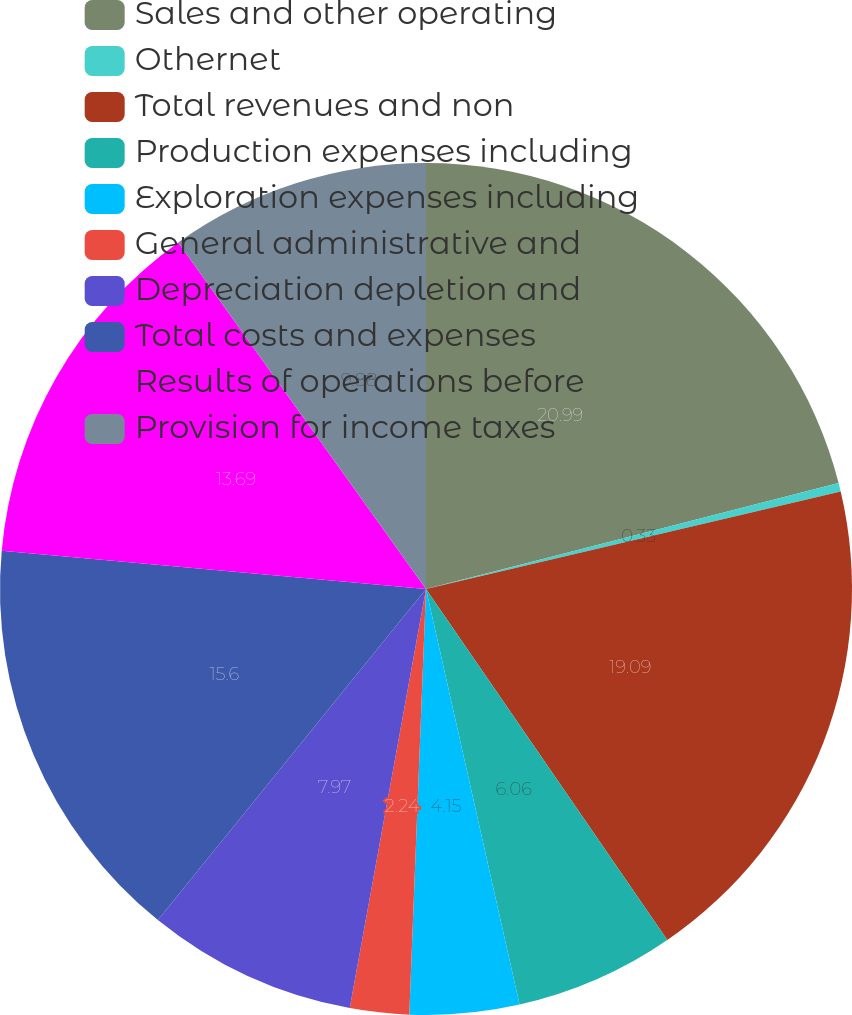<chart> <loc_0><loc_0><loc_500><loc_500><pie_chart><fcel>Sales and other operating<fcel>Othernet<fcel>Total revenues and non<fcel>Production expenses including<fcel>Exploration expenses including<fcel>General administrative and<fcel>Depreciation depletion and<fcel>Total costs and expenses<fcel>Results of operations before<fcel>Provision for income taxes<nl><fcel>21.0%<fcel>0.33%<fcel>19.09%<fcel>6.06%<fcel>4.15%<fcel>2.24%<fcel>7.97%<fcel>15.6%<fcel>13.69%<fcel>9.88%<nl></chart> 